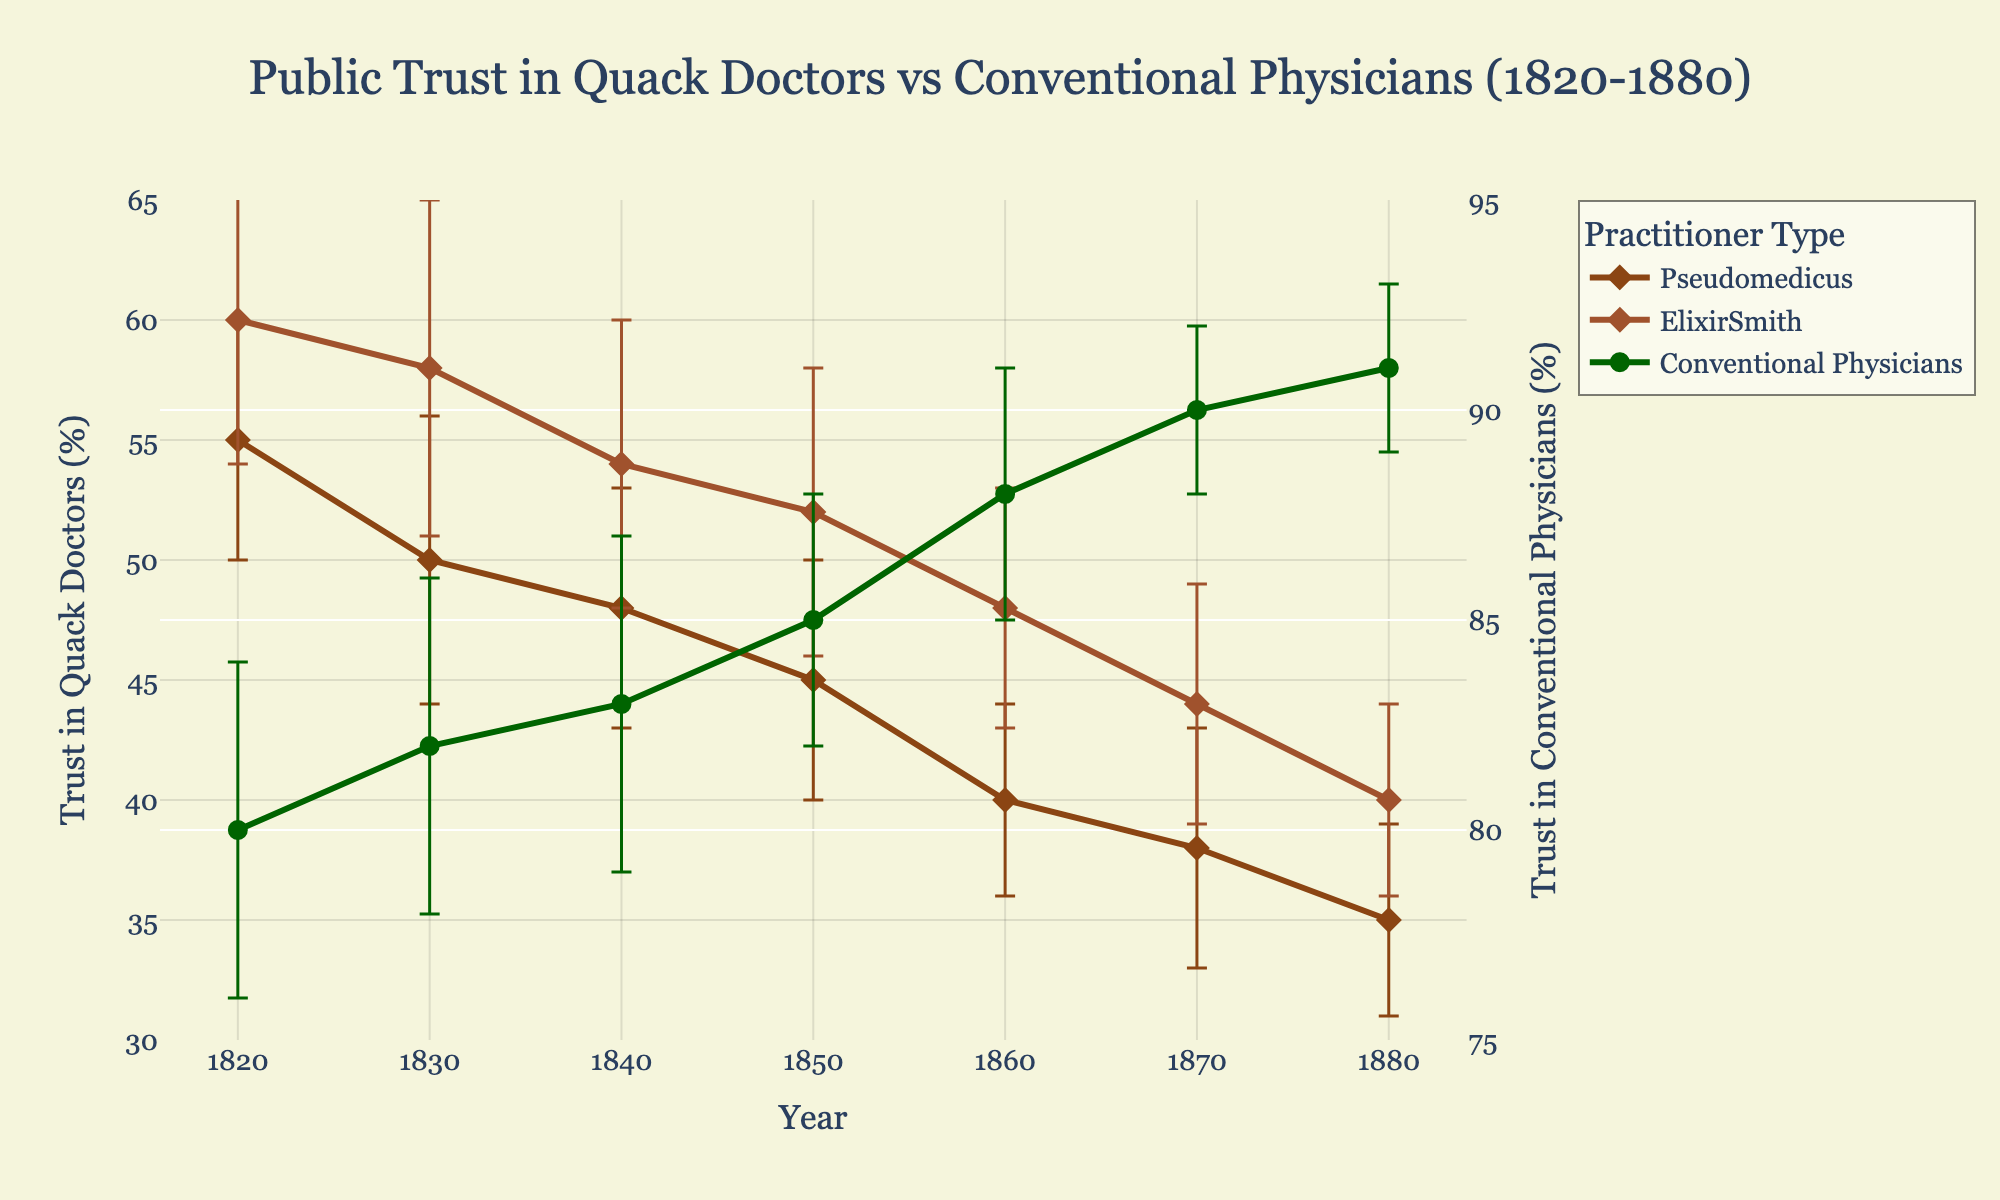What's the title of the plot? The title is prominently displayed at the top center of the plot in a larger font. It reads 'Public Trust in Quack Doctors vs Conventional Physicians (1820-1880)'
Answer: Public Trust in Quack Doctors vs Conventional Physicians (1820-1880) How many different types of practitioners are represented in the plot? There are three distinct practitioner types represented in the legend of the plot: two quack doctors and conventional physicians.
Answer: 3 What is the color of the line representing Conventional Physicians? The color representing Conventional Physicians is dark green, as shown in the plot.
Answer: Dark green In what year did QuackDoctor_ElixirSmith have the highest trust value and what was it? QuackDoctor_ElixirSmith had the highest trust value in the year 1820, where the trust value was 60. This can be observed from the data points on the plot.
Answer: 1820 and 60 How many years are shown on the x-axis? The x-axis displays years from 1820 to 1880, inclusive. Counting each decade, there are 7 years in total.
Answer: 7 Which practitioner's trust decreased the most from 1820 to 1880? By finding the difference between 1820 and 1880 for each practitioner, we see that QuackDoctor_ElixirSmith's trust dropped from 60 to 40 (a decrease of 20), QuackDoctor_Pseudomedicus's trust dropped from 55 to 35 (a decrease of 20), and Conventional Physicians' trust increased from 80 to 91 (an increase of 11). Hence, either QuackDoctor_ElixirSmith or QuackDoctor_Pseudomedicus had the greatest decrease, both by 20.
Answer: QuackDoctor_ElixirSmith or QuackDoctor_Pseudomedicus What is the average trust value for Conventional Physicians over the decades shown? To find the average trust value for Conventional Physicians, sum their trust values for each decade (80 + 82 + 83 + 85 + 88 + 90 + 91) which equals 599, and divide by the number of data points (7). The average is 599/7 ≈ 85.57.
Answer: 85.57 In 1840, which practitioner had the highest error bar value and what is it? The error bars for each practitioner in 1840 are 5 for QuackDoctor_Pseudomedicus, 6 for QuackDoctor_ElixirSmith, and 4 for Conventional Physicians. Hence, QuackDoctor_ElixirSmith had the highest error bar value of 6.
Answer: QuackDoctor_ElixirSmith and 6 Is the trust in Conventional Physicians increasing or decreasing over time? By observing the trend line for Conventional Physicians from 1820 to 1880, it is clear that the trust values are increasing each decade (from 80 to 91).
Answer: Increasing Between 1820 and 1880, how does the trust in QuackDoctor_Pseudomedicus compare to that in QuackDoctor_ElixirSmith in 1870? In 1870, the trust value for QuackDoctor_Pseudomedicus was 38, while for QuackDoctor_ElixirSmith it was 44. Therefore, QuackDoctor_ElixirSmith had a higher trust value of 6 more than QuackDoctor_Pseudomedicus.
Answer: QuackDoctor_ElixirSmith higher by 6 